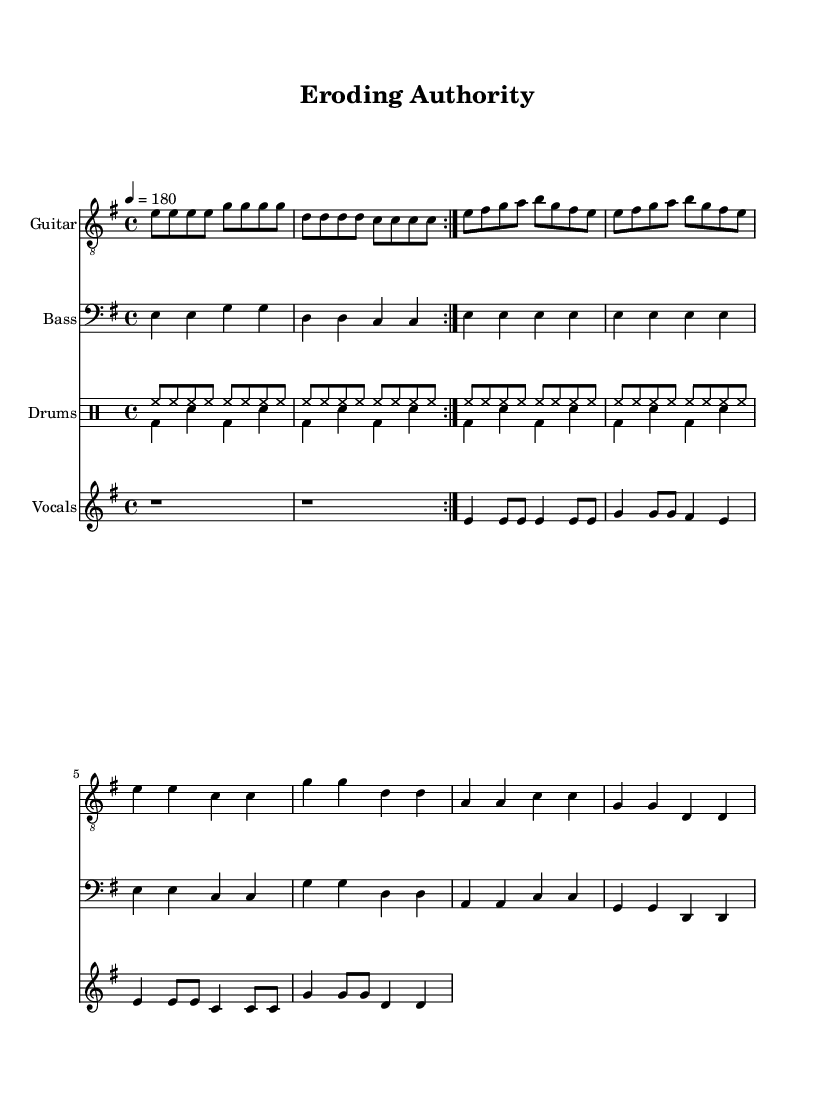What is the key signature of this music? The key signature is indicated at the beginning of the staff, which shows one sharp (F#). This means it is in the key of E minor.
Answer: E minor What is the time signature of this piece? The time signature is found just after the key signature at the beginning, which displays 4/4 time. This indicates there are four beats in each measure and a quarter note equals one beat.
Answer: 4/4 What is the tempo marking for this piece? The tempo is indicated in beats per minute (BPM) and is found at the beginning of the score. It specifies a tempo of 180 beats per minute.
Answer: 180 How many measures are in the Verse section? By analyzing the staff notation, we can see that the verse section has a total of 8 measures, which can be counted from the music provided.
Answer: 8 Which instrument has the melodic line for the lyrics? The lyrics are connected to the melody, which is represented by the vocal staff. The melody line for the lyrics appears in the vocal part of the score.
Answer: Vocals What type of beat predominates in the drum sections? The drum sections use a common punk rock beat, characterized by a steady hi-hat pattern and alternating bass and snare hits. This rhythm is fundamental to the punk genre.
Answer: Punk beat What themes are reflected in the lyrics? The lyrics discuss themes of environmental destruction and rebellion against authority, which resonate with common anarcho-punk themes related to social issues and activism.
Answer: Environmental destruction 